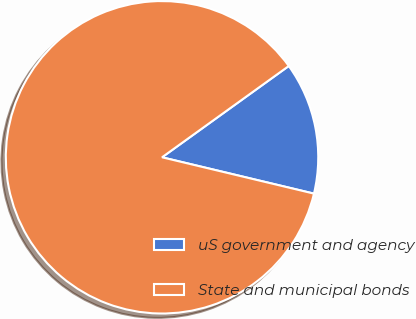Convert chart. <chart><loc_0><loc_0><loc_500><loc_500><pie_chart><fcel>uS government and agency<fcel>State and municipal bonds<nl><fcel>13.67%<fcel>86.33%<nl></chart> 